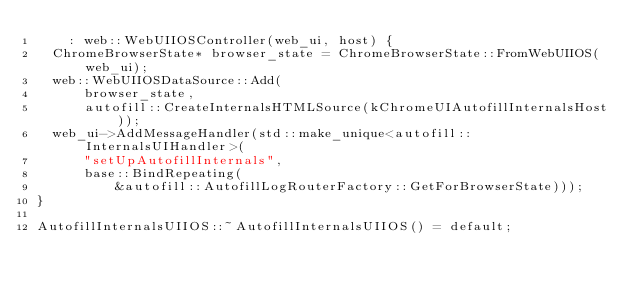<code> <loc_0><loc_0><loc_500><loc_500><_ObjectiveC_>    : web::WebUIIOSController(web_ui, host) {
  ChromeBrowserState* browser_state = ChromeBrowserState::FromWebUIIOS(web_ui);
  web::WebUIIOSDataSource::Add(
      browser_state,
      autofill::CreateInternalsHTMLSource(kChromeUIAutofillInternalsHost));
  web_ui->AddMessageHandler(std::make_unique<autofill::InternalsUIHandler>(
      "setUpAutofillInternals",
      base::BindRepeating(
          &autofill::AutofillLogRouterFactory::GetForBrowserState)));
}

AutofillInternalsUIIOS::~AutofillInternalsUIIOS() = default;
</code> 